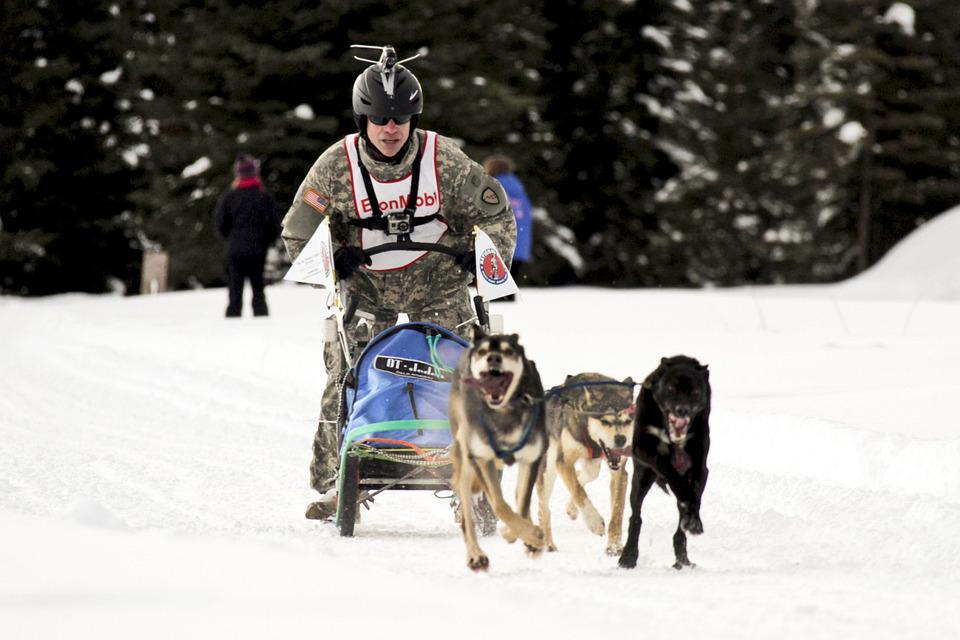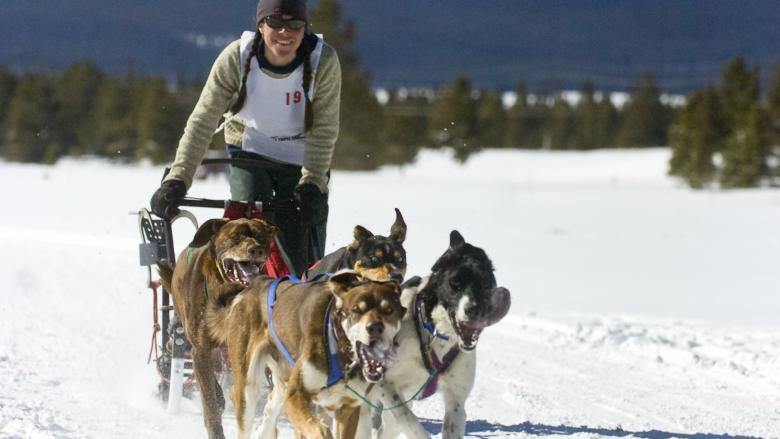The first image is the image on the left, the second image is the image on the right. Assess this claim about the two images: "There are multiple persons being pulled by the dogs in the image on the left.". Correct or not? Answer yes or no. No. 